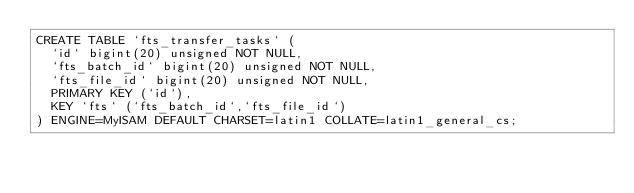Convert code to text. <code><loc_0><loc_0><loc_500><loc_500><_SQL_>CREATE TABLE `fts_transfer_tasks` (
  `id` bigint(20) unsigned NOT NULL,
  `fts_batch_id` bigint(20) unsigned NOT NULL,
  `fts_file_id` bigint(20) unsigned NOT NULL,
  PRIMARY KEY (`id`),
  KEY `fts` (`fts_batch_id`,`fts_file_id`)
) ENGINE=MyISAM DEFAULT CHARSET=latin1 COLLATE=latin1_general_cs;
</code> 